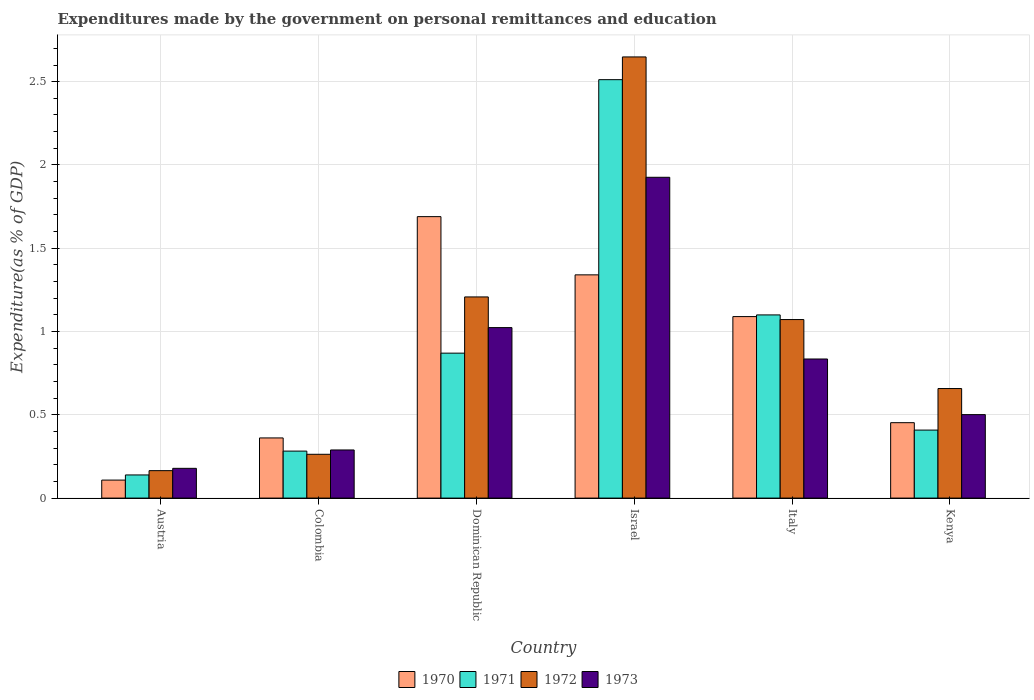How many bars are there on the 5th tick from the left?
Your response must be concise. 4. In how many cases, is the number of bars for a given country not equal to the number of legend labels?
Make the answer very short. 0. What is the expenditures made by the government on personal remittances and education in 1973 in Colombia?
Your answer should be compact. 0.29. Across all countries, what is the maximum expenditures made by the government on personal remittances and education in 1973?
Ensure brevity in your answer.  1.93. Across all countries, what is the minimum expenditures made by the government on personal remittances and education in 1972?
Provide a short and direct response. 0.16. In which country was the expenditures made by the government on personal remittances and education in 1972 maximum?
Give a very brief answer. Israel. What is the total expenditures made by the government on personal remittances and education in 1973 in the graph?
Provide a succinct answer. 4.75. What is the difference between the expenditures made by the government on personal remittances and education in 1972 in Colombia and that in Dominican Republic?
Offer a very short reply. -0.94. What is the difference between the expenditures made by the government on personal remittances and education in 1973 in Kenya and the expenditures made by the government on personal remittances and education in 1972 in Dominican Republic?
Make the answer very short. -0.71. What is the average expenditures made by the government on personal remittances and education in 1970 per country?
Offer a terse response. 0.84. What is the difference between the expenditures made by the government on personal remittances and education of/in 1972 and expenditures made by the government on personal remittances and education of/in 1970 in Italy?
Make the answer very short. -0.02. In how many countries, is the expenditures made by the government on personal remittances and education in 1971 greater than 0.4 %?
Offer a very short reply. 4. What is the ratio of the expenditures made by the government on personal remittances and education in 1972 in Austria to that in Dominican Republic?
Ensure brevity in your answer.  0.14. Is the expenditures made by the government on personal remittances and education in 1970 in Israel less than that in Kenya?
Your answer should be very brief. No. What is the difference between the highest and the second highest expenditures made by the government on personal remittances and education in 1971?
Make the answer very short. -0.23. What is the difference between the highest and the lowest expenditures made by the government on personal remittances and education in 1973?
Your answer should be compact. 1.75. In how many countries, is the expenditures made by the government on personal remittances and education in 1972 greater than the average expenditures made by the government on personal remittances and education in 1972 taken over all countries?
Keep it short and to the point. 3. Is it the case that in every country, the sum of the expenditures made by the government on personal remittances and education in 1970 and expenditures made by the government on personal remittances and education in 1972 is greater than the sum of expenditures made by the government on personal remittances and education in 1971 and expenditures made by the government on personal remittances and education in 1973?
Make the answer very short. No. What does the 3rd bar from the right in Israel represents?
Give a very brief answer. 1971. Is it the case that in every country, the sum of the expenditures made by the government on personal remittances and education in 1972 and expenditures made by the government on personal remittances and education in 1970 is greater than the expenditures made by the government on personal remittances and education in 1971?
Offer a terse response. Yes. Are all the bars in the graph horizontal?
Your answer should be very brief. No. How many countries are there in the graph?
Ensure brevity in your answer.  6. Does the graph contain any zero values?
Provide a succinct answer. No. Does the graph contain grids?
Give a very brief answer. Yes. Where does the legend appear in the graph?
Provide a short and direct response. Bottom center. How many legend labels are there?
Provide a succinct answer. 4. How are the legend labels stacked?
Your answer should be very brief. Horizontal. What is the title of the graph?
Your answer should be very brief. Expenditures made by the government on personal remittances and education. What is the label or title of the Y-axis?
Keep it short and to the point. Expenditure(as % of GDP). What is the Expenditure(as % of GDP) in 1970 in Austria?
Your response must be concise. 0.11. What is the Expenditure(as % of GDP) in 1971 in Austria?
Your response must be concise. 0.14. What is the Expenditure(as % of GDP) in 1972 in Austria?
Provide a short and direct response. 0.16. What is the Expenditure(as % of GDP) of 1973 in Austria?
Your answer should be very brief. 0.18. What is the Expenditure(as % of GDP) of 1970 in Colombia?
Keep it short and to the point. 0.36. What is the Expenditure(as % of GDP) of 1971 in Colombia?
Make the answer very short. 0.28. What is the Expenditure(as % of GDP) in 1972 in Colombia?
Provide a short and direct response. 0.26. What is the Expenditure(as % of GDP) in 1973 in Colombia?
Give a very brief answer. 0.29. What is the Expenditure(as % of GDP) of 1970 in Dominican Republic?
Your answer should be compact. 1.69. What is the Expenditure(as % of GDP) of 1971 in Dominican Republic?
Keep it short and to the point. 0.87. What is the Expenditure(as % of GDP) of 1972 in Dominican Republic?
Ensure brevity in your answer.  1.21. What is the Expenditure(as % of GDP) in 1973 in Dominican Republic?
Your response must be concise. 1.02. What is the Expenditure(as % of GDP) of 1970 in Israel?
Your answer should be compact. 1.34. What is the Expenditure(as % of GDP) in 1971 in Israel?
Your answer should be compact. 2.51. What is the Expenditure(as % of GDP) in 1972 in Israel?
Your response must be concise. 2.65. What is the Expenditure(as % of GDP) in 1973 in Israel?
Your response must be concise. 1.93. What is the Expenditure(as % of GDP) of 1970 in Italy?
Your answer should be very brief. 1.09. What is the Expenditure(as % of GDP) in 1971 in Italy?
Provide a short and direct response. 1.1. What is the Expenditure(as % of GDP) in 1972 in Italy?
Offer a very short reply. 1.07. What is the Expenditure(as % of GDP) of 1973 in Italy?
Ensure brevity in your answer.  0.84. What is the Expenditure(as % of GDP) in 1970 in Kenya?
Your response must be concise. 0.45. What is the Expenditure(as % of GDP) of 1971 in Kenya?
Offer a very short reply. 0.41. What is the Expenditure(as % of GDP) in 1972 in Kenya?
Provide a short and direct response. 0.66. What is the Expenditure(as % of GDP) of 1973 in Kenya?
Your response must be concise. 0.5. Across all countries, what is the maximum Expenditure(as % of GDP) of 1970?
Offer a terse response. 1.69. Across all countries, what is the maximum Expenditure(as % of GDP) of 1971?
Your response must be concise. 2.51. Across all countries, what is the maximum Expenditure(as % of GDP) in 1972?
Ensure brevity in your answer.  2.65. Across all countries, what is the maximum Expenditure(as % of GDP) in 1973?
Provide a succinct answer. 1.93. Across all countries, what is the minimum Expenditure(as % of GDP) in 1970?
Provide a succinct answer. 0.11. Across all countries, what is the minimum Expenditure(as % of GDP) of 1971?
Provide a short and direct response. 0.14. Across all countries, what is the minimum Expenditure(as % of GDP) in 1972?
Give a very brief answer. 0.16. Across all countries, what is the minimum Expenditure(as % of GDP) in 1973?
Your response must be concise. 0.18. What is the total Expenditure(as % of GDP) in 1970 in the graph?
Your answer should be very brief. 5.04. What is the total Expenditure(as % of GDP) of 1971 in the graph?
Your answer should be very brief. 5.31. What is the total Expenditure(as % of GDP) in 1972 in the graph?
Make the answer very short. 6.01. What is the total Expenditure(as % of GDP) of 1973 in the graph?
Give a very brief answer. 4.75. What is the difference between the Expenditure(as % of GDP) in 1970 in Austria and that in Colombia?
Give a very brief answer. -0.25. What is the difference between the Expenditure(as % of GDP) of 1971 in Austria and that in Colombia?
Make the answer very short. -0.14. What is the difference between the Expenditure(as % of GDP) of 1972 in Austria and that in Colombia?
Offer a terse response. -0.1. What is the difference between the Expenditure(as % of GDP) of 1973 in Austria and that in Colombia?
Make the answer very short. -0.11. What is the difference between the Expenditure(as % of GDP) of 1970 in Austria and that in Dominican Republic?
Your response must be concise. -1.58. What is the difference between the Expenditure(as % of GDP) in 1971 in Austria and that in Dominican Republic?
Your answer should be very brief. -0.73. What is the difference between the Expenditure(as % of GDP) in 1972 in Austria and that in Dominican Republic?
Give a very brief answer. -1.04. What is the difference between the Expenditure(as % of GDP) of 1973 in Austria and that in Dominican Republic?
Keep it short and to the point. -0.84. What is the difference between the Expenditure(as % of GDP) of 1970 in Austria and that in Israel?
Your answer should be very brief. -1.23. What is the difference between the Expenditure(as % of GDP) of 1971 in Austria and that in Israel?
Your answer should be compact. -2.37. What is the difference between the Expenditure(as % of GDP) in 1972 in Austria and that in Israel?
Ensure brevity in your answer.  -2.48. What is the difference between the Expenditure(as % of GDP) in 1973 in Austria and that in Israel?
Provide a succinct answer. -1.75. What is the difference between the Expenditure(as % of GDP) of 1970 in Austria and that in Italy?
Offer a terse response. -0.98. What is the difference between the Expenditure(as % of GDP) of 1971 in Austria and that in Italy?
Keep it short and to the point. -0.96. What is the difference between the Expenditure(as % of GDP) of 1972 in Austria and that in Italy?
Provide a short and direct response. -0.91. What is the difference between the Expenditure(as % of GDP) of 1973 in Austria and that in Italy?
Make the answer very short. -0.66. What is the difference between the Expenditure(as % of GDP) of 1970 in Austria and that in Kenya?
Provide a succinct answer. -0.34. What is the difference between the Expenditure(as % of GDP) of 1971 in Austria and that in Kenya?
Your answer should be compact. -0.27. What is the difference between the Expenditure(as % of GDP) of 1972 in Austria and that in Kenya?
Keep it short and to the point. -0.49. What is the difference between the Expenditure(as % of GDP) of 1973 in Austria and that in Kenya?
Provide a succinct answer. -0.32. What is the difference between the Expenditure(as % of GDP) in 1970 in Colombia and that in Dominican Republic?
Provide a short and direct response. -1.33. What is the difference between the Expenditure(as % of GDP) of 1971 in Colombia and that in Dominican Republic?
Provide a succinct answer. -0.59. What is the difference between the Expenditure(as % of GDP) in 1972 in Colombia and that in Dominican Republic?
Give a very brief answer. -0.94. What is the difference between the Expenditure(as % of GDP) of 1973 in Colombia and that in Dominican Republic?
Your response must be concise. -0.73. What is the difference between the Expenditure(as % of GDP) of 1970 in Colombia and that in Israel?
Offer a terse response. -0.98. What is the difference between the Expenditure(as % of GDP) in 1971 in Colombia and that in Israel?
Provide a short and direct response. -2.23. What is the difference between the Expenditure(as % of GDP) of 1972 in Colombia and that in Israel?
Your answer should be very brief. -2.39. What is the difference between the Expenditure(as % of GDP) in 1973 in Colombia and that in Israel?
Give a very brief answer. -1.64. What is the difference between the Expenditure(as % of GDP) of 1970 in Colombia and that in Italy?
Offer a very short reply. -0.73. What is the difference between the Expenditure(as % of GDP) of 1971 in Colombia and that in Italy?
Keep it short and to the point. -0.82. What is the difference between the Expenditure(as % of GDP) of 1972 in Colombia and that in Italy?
Ensure brevity in your answer.  -0.81. What is the difference between the Expenditure(as % of GDP) of 1973 in Colombia and that in Italy?
Your answer should be very brief. -0.55. What is the difference between the Expenditure(as % of GDP) of 1970 in Colombia and that in Kenya?
Ensure brevity in your answer.  -0.09. What is the difference between the Expenditure(as % of GDP) in 1971 in Colombia and that in Kenya?
Offer a terse response. -0.13. What is the difference between the Expenditure(as % of GDP) in 1972 in Colombia and that in Kenya?
Provide a short and direct response. -0.39. What is the difference between the Expenditure(as % of GDP) in 1973 in Colombia and that in Kenya?
Ensure brevity in your answer.  -0.21. What is the difference between the Expenditure(as % of GDP) in 1970 in Dominican Republic and that in Israel?
Give a very brief answer. 0.35. What is the difference between the Expenditure(as % of GDP) in 1971 in Dominican Republic and that in Israel?
Provide a succinct answer. -1.64. What is the difference between the Expenditure(as % of GDP) in 1972 in Dominican Republic and that in Israel?
Your response must be concise. -1.44. What is the difference between the Expenditure(as % of GDP) in 1973 in Dominican Republic and that in Israel?
Give a very brief answer. -0.9. What is the difference between the Expenditure(as % of GDP) of 1970 in Dominican Republic and that in Italy?
Ensure brevity in your answer.  0.6. What is the difference between the Expenditure(as % of GDP) in 1971 in Dominican Republic and that in Italy?
Your answer should be very brief. -0.23. What is the difference between the Expenditure(as % of GDP) of 1972 in Dominican Republic and that in Italy?
Make the answer very short. 0.14. What is the difference between the Expenditure(as % of GDP) in 1973 in Dominican Republic and that in Italy?
Offer a terse response. 0.19. What is the difference between the Expenditure(as % of GDP) in 1970 in Dominican Republic and that in Kenya?
Keep it short and to the point. 1.24. What is the difference between the Expenditure(as % of GDP) of 1971 in Dominican Republic and that in Kenya?
Offer a terse response. 0.46. What is the difference between the Expenditure(as % of GDP) of 1972 in Dominican Republic and that in Kenya?
Offer a terse response. 0.55. What is the difference between the Expenditure(as % of GDP) of 1973 in Dominican Republic and that in Kenya?
Your answer should be compact. 0.52. What is the difference between the Expenditure(as % of GDP) of 1970 in Israel and that in Italy?
Make the answer very short. 0.25. What is the difference between the Expenditure(as % of GDP) in 1971 in Israel and that in Italy?
Provide a succinct answer. 1.41. What is the difference between the Expenditure(as % of GDP) of 1972 in Israel and that in Italy?
Offer a very short reply. 1.58. What is the difference between the Expenditure(as % of GDP) in 1973 in Israel and that in Italy?
Your response must be concise. 1.09. What is the difference between the Expenditure(as % of GDP) of 1970 in Israel and that in Kenya?
Make the answer very short. 0.89. What is the difference between the Expenditure(as % of GDP) in 1971 in Israel and that in Kenya?
Make the answer very short. 2.1. What is the difference between the Expenditure(as % of GDP) in 1972 in Israel and that in Kenya?
Provide a short and direct response. 1.99. What is the difference between the Expenditure(as % of GDP) in 1973 in Israel and that in Kenya?
Make the answer very short. 1.42. What is the difference between the Expenditure(as % of GDP) in 1970 in Italy and that in Kenya?
Offer a very short reply. 0.64. What is the difference between the Expenditure(as % of GDP) in 1971 in Italy and that in Kenya?
Give a very brief answer. 0.69. What is the difference between the Expenditure(as % of GDP) of 1972 in Italy and that in Kenya?
Your answer should be very brief. 0.41. What is the difference between the Expenditure(as % of GDP) of 1973 in Italy and that in Kenya?
Provide a short and direct response. 0.33. What is the difference between the Expenditure(as % of GDP) of 1970 in Austria and the Expenditure(as % of GDP) of 1971 in Colombia?
Your answer should be very brief. -0.17. What is the difference between the Expenditure(as % of GDP) of 1970 in Austria and the Expenditure(as % of GDP) of 1972 in Colombia?
Provide a succinct answer. -0.15. What is the difference between the Expenditure(as % of GDP) of 1970 in Austria and the Expenditure(as % of GDP) of 1973 in Colombia?
Your answer should be very brief. -0.18. What is the difference between the Expenditure(as % of GDP) in 1971 in Austria and the Expenditure(as % of GDP) in 1972 in Colombia?
Your response must be concise. -0.12. What is the difference between the Expenditure(as % of GDP) of 1971 in Austria and the Expenditure(as % of GDP) of 1973 in Colombia?
Keep it short and to the point. -0.15. What is the difference between the Expenditure(as % of GDP) in 1972 in Austria and the Expenditure(as % of GDP) in 1973 in Colombia?
Provide a short and direct response. -0.12. What is the difference between the Expenditure(as % of GDP) of 1970 in Austria and the Expenditure(as % of GDP) of 1971 in Dominican Republic?
Keep it short and to the point. -0.76. What is the difference between the Expenditure(as % of GDP) of 1970 in Austria and the Expenditure(as % of GDP) of 1972 in Dominican Republic?
Give a very brief answer. -1.1. What is the difference between the Expenditure(as % of GDP) in 1970 in Austria and the Expenditure(as % of GDP) in 1973 in Dominican Republic?
Make the answer very short. -0.92. What is the difference between the Expenditure(as % of GDP) of 1971 in Austria and the Expenditure(as % of GDP) of 1972 in Dominican Republic?
Offer a terse response. -1.07. What is the difference between the Expenditure(as % of GDP) of 1971 in Austria and the Expenditure(as % of GDP) of 1973 in Dominican Republic?
Provide a short and direct response. -0.88. What is the difference between the Expenditure(as % of GDP) of 1972 in Austria and the Expenditure(as % of GDP) of 1973 in Dominican Republic?
Offer a terse response. -0.86. What is the difference between the Expenditure(as % of GDP) of 1970 in Austria and the Expenditure(as % of GDP) of 1971 in Israel?
Give a very brief answer. -2.4. What is the difference between the Expenditure(as % of GDP) in 1970 in Austria and the Expenditure(as % of GDP) in 1972 in Israel?
Provide a short and direct response. -2.54. What is the difference between the Expenditure(as % of GDP) of 1970 in Austria and the Expenditure(as % of GDP) of 1973 in Israel?
Offer a terse response. -1.82. What is the difference between the Expenditure(as % of GDP) of 1971 in Austria and the Expenditure(as % of GDP) of 1972 in Israel?
Ensure brevity in your answer.  -2.51. What is the difference between the Expenditure(as % of GDP) of 1971 in Austria and the Expenditure(as % of GDP) of 1973 in Israel?
Provide a succinct answer. -1.79. What is the difference between the Expenditure(as % of GDP) of 1972 in Austria and the Expenditure(as % of GDP) of 1973 in Israel?
Give a very brief answer. -1.76. What is the difference between the Expenditure(as % of GDP) of 1970 in Austria and the Expenditure(as % of GDP) of 1971 in Italy?
Offer a terse response. -0.99. What is the difference between the Expenditure(as % of GDP) in 1970 in Austria and the Expenditure(as % of GDP) in 1972 in Italy?
Make the answer very short. -0.96. What is the difference between the Expenditure(as % of GDP) in 1970 in Austria and the Expenditure(as % of GDP) in 1973 in Italy?
Give a very brief answer. -0.73. What is the difference between the Expenditure(as % of GDP) of 1971 in Austria and the Expenditure(as % of GDP) of 1972 in Italy?
Provide a short and direct response. -0.93. What is the difference between the Expenditure(as % of GDP) of 1971 in Austria and the Expenditure(as % of GDP) of 1973 in Italy?
Your answer should be compact. -0.7. What is the difference between the Expenditure(as % of GDP) in 1972 in Austria and the Expenditure(as % of GDP) in 1973 in Italy?
Provide a short and direct response. -0.67. What is the difference between the Expenditure(as % of GDP) in 1970 in Austria and the Expenditure(as % of GDP) in 1971 in Kenya?
Offer a very short reply. -0.3. What is the difference between the Expenditure(as % of GDP) of 1970 in Austria and the Expenditure(as % of GDP) of 1972 in Kenya?
Provide a short and direct response. -0.55. What is the difference between the Expenditure(as % of GDP) in 1970 in Austria and the Expenditure(as % of GDP) in 1973 in Kenya?
Provide a succinct answer. -0.39. What is the difference between the Expenditure(as % of GDP) in 1971 in Austria and the Expenditure(as % of GDP) in 1972 in Kenya?
Your response must be concise. -0.52. What is the difference between the Expenditure(as % of GDP) of 1971 in Austria and the Expenditure(as % of GDP) of 1973 in Kenya?
Provide a short and direct response. -0.36. What is the difference between the Expenditure(as % of GDP) in 1972 in Austria and the Expenditure(as % of GDP) in 1973 in Kenya?
Your answer should be very brief. -0.34. What is the difference between the Expenditure(as % of GDP) of 1970 in Colombia and the Expenditure(as % of GDP) of 1971 in Dominican Republic?
Your response must be concise. -0.51. What is the difference between the Expenditure(as % of GDP) of 1970 in Colombia and the Expenditure(as % of GDP) of 1972 in Dominican Republic?
Your answer should be very brief. -0.85. What is the difference between the Expenditure(as % of GDP) in 1970 in Colombia and the Expenditure(as % of GDP) in 1973 in Dominican Republic?
Offer a very short reply. -0.66. What is the difference between the Expenditure(as % of GDP) of 1971 in Colombia and the Expenditure(as % of GDP) of 1972 in Dominican Republic?
Ensure brevity in your answer.  -0.93. What is the difference between the Expenditure(as % of GDP) in 1971 in Colombia and the Expenditure(as % of GDP) in 1973 in Dominican Republic?
Provide a short and direct response. -0.74. What is the difference between the Expenditure(as % of GDP) in 1972 in Colombia and the Expenditure(as % of GDP) in 1973 in Dominican Republic?
Your answer should be compact. -0.76. What is the difference between the Expenditure(as % of GDP) of 1970 in Colombia and the Expenditure(as % of GDP) of 1971 in Israel?
Offer a terse response. -2.15. What is the difference between the Expenditure(as % of GDP) of 1970 in Colombia and the Expenditure(as % of GDP) of 1972 in Israel?
Your response must be concise. -2.29. What is the difference between the Expenditure(as % of GDP) of 1970 in Colombia and the Expenditure(as % of GDP) of 1973 in Israel?
Your answer should be compact. -1.56. What is the difference between the Expenditure(as % of GDP) of 1971 in Colombia and the Expenditure(as % of GDP) of 1972 in Israel?
Keep it short and to the point. -2.37. What is the difference between the Expenditure(as % of GDP) in 1971 in Colombia and the Expenditure(as % of GDP) in 1973 in Israel?
Keep it short and to the point. -1.64. What is the difference between the Expenditure(as % of GDP) of 1972 in Colombia and the Expenditure(as % of GDP) of 1973 in Israel?
Give a very brief answer. -1.66. What is the difference between the Expenditure(as % of GDP) of 1970 in Colombia and the Expenditure(as % of GDP) of 1971 in Italy?
Offer a terse response. -0.74. What is the difference between the Expenditure(as % of GDP) in 1970 in Colombia and the Expenditure(as % of GDP) in 1972 in Italy?
Offer a very short reply. -0.71. What is the difference between the Expenditure(as % of GDP) of 1970 in Colombia and the Expenditure(as % of GDP) of 1973 in Italy?
Your response must be concise. -0.47. What is the difference between the Expenditure(as % of GDP) in 1971 in Colombia and the Expenditure(as % of GDP) in 1972 in Italy?
Keep it short and to the point. -0.79. What is the difference between the Expenditure(as % of GDP) in 1971 in Colombia and the Expenditure(as % of GDP) in 1973 in Italy?
Keep it short and to the point. -0.55. What is the difference between the Expenditure(as % of GDP) of 1972 in Colombia and the Expenditure(as % of GDP) of 1973 in Italy?
Give a very brief answer. -0.57. What is the difference between the Expenditure(as % of GDP) in 1970 in Colombia and the Expenditure(as % of GDP) in 1971 in Kenya?
Offer a terse response. -0.05. What is the difference between the Expenditure(as % of GDP) in 1970 in Colombia and the Expenditure(as % of GDP) in 1972 in Kenya?
Ensure brevity in your answer.  -0.3. What is the difference between the Expenditure(as % of GDP) in 1970 in Colombia and the Expenditure(as % of GDP) in 1973 in Kenya?
Offer a very short reply. -0.14. What is the difference between the Expenditure(as % of GDP) in 1971 in Colombia and the Expenditure(as % of GDP) in 1972 in Kenya?
Offer a very short reply. -0.38. What is the difference between the Expenditure(as % of GDP) of 1971 in Colombia and the Expenditure(as % of GDP) of 1973 in Kenya?
Provide a succinct answer. -0.22. What is the difference between the Expenditure(as % of GDP) of 1972 in Colombia and the Expenditure(as % of GDP) of 1973 in Kenya?
Provide a short and direct response. -0.24. What is the difference between the Expenditure(as % of GDP) of 1970 in Dominican Republic and the Expenditure(as % of GDP) of 1971 in Israel?
Make the answer very short. -0.82. What is the difference between the Expenditure(as % of GDP) in 1970 in Dominican Republic and the Expenditure(as % of GDP) in 1972 in Israel?
Keep it short and to the point. -0.96. What is the difference between the Expenditure(as % of GDP) in 1970 in Dominican Republic and the Expenditure(as % of GDP) in 1973 in Israel?
Keep it short and to the point. -0.24. What is the difference between the Expenditure(as % of GDP) of 1971 in Dominican Republic and the Expenditure(as % of GDP) of 1972 in Israel?
Provide a succinct answer. -1.78. What is the difference between the Expenditure(as % of GDP) in 1971 in Dominican Republic and the Expenditure(as % of GDP) in 1973 in Israel?
Your answer should be very brief. -1.06. What is the difference between the Expenditure(as % of GDP) of 1972 in Dominican Republic and the Expenditure(as % of GDP) of 1973 in Israel?
Your response must be concise. -0.72. What is the difference between the Expenditure(as % of GDP) in 1970 in Dominican Republic and the Expenditure(as % of GDP) in 1971 in Italy?
Your answer should be very brief. 0.59. What is the difference between the Expenditure(as % of GDP) of 1970 in Dominican Republic and the Expenditure(as % of GDP) of 1972 in Italy?
Your response must be concise. 0.62. What is the difference between the Expenditure(as % of GDP) in 1970 in Dominican Republic and the Expenditure(as % of GDP) in 1973 in Italy?
Provide a short and direct response. 0.85. What is the difference between the Expenditure(as % of GDP) in 1971 in Dominican Republic and the Expenditure(as % of GDP) in 1972 in Italy?
Provide a short and direct response. -0.2. What is the difference between the Expenditure(as % of GDP) in 1971 in Dominican Republic and the Expenditure(as % of GDP) in 1973 in Italy?
Your answer should be very brief. 0.04. What is the difference between the Expenditure(as % of GDP) in 1972 in Dominican Republic and the Expenditure(as % of GDP) in 1973 in Italy?
Ensure brevity in your answer.  0.37. What is the difference between the Expenditure(as % of GDP) of 1970 in Dominican Republic and the Expenditure(as % of GDP) of 1971 in Kenya?
Keep it short and to the point. 1.28. What is the difference between the Expenditure(as % of GDP) of 1970 in Dominican Republic and the Expenditure(as % of GDP) of 1972 in Kenya?
Ensure brevity in your answer.  1.03. What is the difference between the Expenditure(as % of GDP) of 1970 in Dominican Republic and the Expenditure(as % of GDP) of 1973 in Kenya?
Provide a succinct answer. 1.19. What is the difference between the Expenditure(as % of GDP) in 1971 in Dominican Republic and the Expenditure(as % of GDP) in 1972 in Kenya?
Your answer should be very brief. 0.21. What is the difference between the Expenditure(as % of GDP) in 1971 in Dominican Republic and the Expenditure(as % of GDP) in 1973 in Kenya?
Ensure brevity in your answer.  0.37. What is the difference between the Expenditure(as % of GDP) of 1972 in Dominican Republic and the Expenditure(as % of GDP) of 1973 in Kenya?
Offer a very short reply. 0.71. What is the difference between the Expenditure(as % of GDP) of 1970 in Israel and the Expenditure(as % of GDP) of 1971 in Italy?
Make the answer very short. 0.24. What is the difference between the Expenditure(as % of GDP) in 1970 in Israel and the Expenditure(as % of GDP) in 1972 in Italy?
Offer a very short reply. 0.27. What is the difference between the Expenditure(as % of GDP) in 1970 in Israel and the Expenditure(as % of GDP) in 1973 in Italy?
Your answer should be very brief. 0.51. What is the difference between the Expenditure(as % of GDP) of 1971 in Israel and the Expenditure(as % of GDP) of 1972 in Italy?
Give a very brief answer. 1.44. What is the difference between the Expenditure(as % of GDP) in 1971 in Israel and the Expenditure(as % of GDP) in 1973 in Italy?
Give a very brief answer. 1.68. What is the difference between the Expenditure(as % of GDP) in 1972 in Israel and the Expenditure(as % of GDP) in 1973 in Italy?
Give a very brief answer. 1.81. What is the difference between the Expenditure(as % of GDP) in 1970 in Israel and the Expenditure(as % of GDP) in 1971 in Kenya?
Make the answer very short. 0.93. What is the difference between the Expenditure(as % of GDP) of 1970 in Israel and the Expenditure(as % of GDP) of 1972 in Kenya?
Ensure brevity in your answer.  0.68. What is the difference between the Expenditure(as % of GDP) in 1970 in Israel and the Expenditure(as % of GDP) in 1973 in Kenya?
Your answer should be very brief. 0.84. What is the difference between the Expenditure(as % of GDP) in 1971 in Israel and the Expenditure(as % of GDP) in 1972 in Kenya?
Provide a succinct answer. 1.85. What is the difference between the Expenditure(as % of GDP) in 1971 in Israel and the Expenditure(as % of GDP) in 1973 in Kenya?
Provide a short and direct response. 2.01. What is the difference between the Expenditure(as % of GDP) in 1972 in Israel and the Expenditure(as % of GDP) in 1973 in Kenya?
Offer a terse response. 2.15. What is the difference between the Expenditure(as % of GDP) of 1970 in Italy and the Expenditure(as % of GDP) of 1971 in Kenya?
Ensure brevity in your answer.  0.68. What is the difference between the Expenditure(as % of GDP) in 1970 in Italy and the Expenditure(as % of GDP) in 1972 in Kenya?
Provide a succinct answer. 0.43. What is the difference between the Expenditure(as % of GDP) of 1970 in Italy and the Expenditure(as % of GDP) of 1973 in Kenya?
Your answer should be very brief. 0.59. What is the difference between the Expenditure(as % of GDP) in 1971 in Italy and the Expenditure(as % of GDP) in 1972 in Kenya?
Ensure brevity in your answer.  0.44. What is the difference between the Expenditure(as % of GDP) of 1971 in Italy and the Expenditure(as % of GDP) of 1973 in Kenya?
Your answer should be very brief. 0.6. What is the difference between the Expenditure(as % of GDP) of 1972 in Italy and the Expenditure(as % of GDP) of 1973 in Kenya?
Your answer should be compact. 0.57. What is the average Expenditure(as % of GDP) in 1970 per country?
Your response must be concise. 0.84. What is the average Expenditure(as % of GDP) of 1971 per country?
Your answer should be compact. 0.89. What is the average Expenditure(as % of GDP) in 1972 per country?
Offer a terse response. 1. What is the average Expenditure(as % of GDP) in 1973 per country?
Provide a succinct answer. 0.79. What is the difference between the Expenditure(as % of GDP) in 1970 and Expenditure(as % of GDP) in 1971 in Austria?
Provide a succinct answer. -0.03. What is the difference between the Expenditure(as % of GDP) of 1970 and Expenditure(as % of GDP) of 1972 in Austria?
Give a very brief answer. -0.06. What is the difference between the Expenditure(as % of GDP) of 1970 and Expenditure(as % of GDP) of 1973 in Austria?
Give a very brief answer. -0.07. What is the difference between the Expenditure(as % of GDP) in 1971 and Expenditure(as % of GDP) in 1972 in Austria?
Your answer should be compact. -0.03. What is the difference between the Expenditure(as % of GDP) in 1971 and Expenditure(as % of GDP) in 1973 in Austria?
Provide a succinct answer. -0.04. What is the difference between the Expenditure(as % of GDP) in 1972 and Expenditure(as % of GDP) in 1973 in Austria?
Your response must be concise. -0.01. What is the difference between the Expenditure(as % of GDP) in 1970 and Expenditure(as % of GDP) in 1971 in Colombia?
Offer a very short reply. 0.08. What is the difference between the Expenditure(as % of GDP) in 1970 and Expenditure(as % of GDP) in 1972 in Colombia?
Offer a terse response. 0.1. What is the difference between the Expenditure(as % of GDP) in 1970 and Expenditure(as % of GDP) in 1973 in Colombia?
Give a very brief answer. 0.07. What is the difference between the Expenditure(as % of GDP) in 1971 and Expenditure(as % of GDP) in 1972 in Colombia?
Provide a succinct answer. 0.02. What is the difference between the Expenditure(as % of GDP) in 1971 and Expenditure(as % of GDP) in 1973 in Colombia?
Your answer should be very brief. -0.01. What is the difference between the Expenditure(as % of GDP) in 1972 and Expenditure(as % of GDP) in 1973 in Colombia?
Provide a short and direct response. -0.03. What is the difference between the Expenditure(as % of GDP) of 1970 and Expenditure(as % of GDP) of 1971 in Dominican Republic?
Your response must be concise. 0.82. What is the difference between the Expenditure(as % of GDP) in 1970 and Expenditure(as % of GDP) in 1972 in Dominican Republic?
Give a very brief answer. 0.48. What is the difference between the Expenditure(as % of GDP) of 1970 and Expenditure(as % of GDP) of 1973 in Dominican Republic?
Your response must be concise. 0.67. What is the difference between the Expenditure(as % of GDP) in 1971 and Expenditure(as % of GDP) in 1972 in Dominican Republic?
Your answer should be very brief. -0.34. What is the difference between the Expenditure(as % of GDP) of 1971 and Expenditure(as % of GDP) of 1973 in Dominican Republic?
Offer a very short reply. -0.15. What is the difference between the Expenditure(as % of GDP) of 1972 and Expenditure(as % of GDP) of 1973 in Dominican Republic?
Give a very brief answer. 0.18. What is the difference between the Expenditure(as % of GDP) in 1970 and Expenditure(as % of GDP) in 1971 in Israel?
Make the answer very short. -1.17. What is the difference between the Expenditure(as % of GDP) of 1970 and Expenditure(as % of GDP) of 1972 in Israel?
Your answer should be very brief. -1.31. What is the difference between the Expenditure(as % of GDP) in 1970 and Expenditure(as % of GDP) in 1973 in Israel?
Provide a short and direct response. -0.59. What is the difference between the Expenditure(as % of GDP) in 1971 and Expenditure(as % of GDP) in 1972 in Israel?
Your response must be concise. -0.14. What is the difference between the Expenditure(as % of GDP) of 1971 and Expenditure(as % of GDP) of 1973 in Israel?
Offer a terse response. 0.59. What is the difference between the Expenditure(as % of GDP) in 1972 and Expenditure(as % of GDP) in 1973 in Israel?
Your answer should be very brief. 0.72. What is the difference between the Expenditure(as % of GDP) in 1970 and Expenditure(as % of GDP) in 1971 in Italy?
Offer a very short reply. -0.01. What is the difference between the Expenditure(as % of GDP) of 1970 and Expenditure(as % of GDP) of 1972 in Italy?
Ensure brevity in your answer.  0.02. What is the difference between the Expenditure(as % of GDP) of 1970 and Expenditure(as % of GDP) of 1973 in Italy?
Ensure brevity in your answer.  0.25. What is the difference between the Expenditure(as % of GDP) in 1971 and Expenditure(as % of GDP) in 1972 in Italy?
Make the answer very short. 0.03. What is the difference between the Expenditure(as % of GDP) of 1971 and Expenditure(as % of GDP) of 1973 in Italy?
Ensure brevity in your answer.  0.26. What is the difference between the Expenditure(as % of GDP) of 1972 and Expenditure(as % of GDP) of 1973 in Italy?
Give a very brief answer. 0.24. What is the difference between the Expenditure(as % of GDP) of 1970 and Expenditure(as % of GDP) of 1971 in Kenya?
Provide a succinct answer. 0.04. What is the difference between the Expenditure(as % of GDP) in 1970 and Expenditure(as % of GDP) in 1972 in Kenya?
Your response must be concise. -0.2. What is the difference between the Expenditure(as % of GDP) in 1970 and Expenditure(as % of GDP) in 1973 in Kenya?
Provide a succinct answer. -0.05. What is the difference between the Expenditure(as % of GDP) in 1971 and Expenditure(as % of GDP) in 1972 in Kenya?
Your response must be concise. -0.25. What is the difference between the Expenditure(as % of GDP) in 1971 and Expenditure(as % of GDP) in 1973 in Kenya?
Offer a very short reply. -0.09. What is the difference between the Expenditure(as % of GDP) of 1972 and Expenditure(as % of GDP) of 1973 in Kenya?
Keep it short and to the point. 0.16. What is the ratio of the Expenditure(as % of GDP) in 1970 in Austria to that in Colombia?
Your answer should be very brief. 0.3. What is the ratio of the Expenditure(as % of GDP) in 1971 in Austria to that in Colombia?
Give a very brief answer. 0.49. What is the ratio of the Expenditure(as % of GDP) in 1972 in Austria to that in Colombia?
Make the answer very short. 0.63. What is the ratio of the Expenditure(as % of GDP) in 1973 in Austria to that in Colombia?
Make the answer very short. 0.62. What is the ratio of the Expenditure(as % of GDP) in 1970 in Austria to that in Dominican Republic?
Give a very brief answer. 0.06. What is the ratio of the Expenditure(as % of GDP) in 1971 in Austria to that in Dominican Republic?
Your response must be concise. 0.16. What is the ratio of the Expenditure(as % of GDP) of 1972 in Austria to that in Dominican Republic?
Your response must be concise. 0.14. What is the ratio of the Expenditure(as % of GDP) of 1973 in Austria to that in Dominican Republic?
Keep it short and to the point. 0.17. What is the ratio of the Expenditure(as % of GDP) in 1970 in Austria to that in Israel?
Provide a succinct answer. 0.08. What is the ratio of the Expenditure(as % of GDP) in 1971 in Austria to that in Israel?
Your answer should be compact. 0.06. What is the ratio of the Expenditure(as % of GDP) in 1972 in Austria to that in Israel?
Ensure brevity in your answer.  0.06. What is the ratio of the Expenditure(as % of GDP) in 1973 in Austria to that in Israel?
Make the answer very short. 0.09. What is the ratio of the Expenditure(as % of GDP) of 1970 in Austria to that in Italy?
Your response must be concise. 0.1. What is the ratio of the Expenditure(as % of GDP) in 1971 in Austria to that in Italy?
Provide a succinct answer. 0.13. What is the ratio of the Expenditure(as % of GDP) of 1972 in Austria to that in Italy?
Ensure brevity in your answer.  0.15. What is the ratio of the Expenditure(as % of GDP) of 1973 in Austria to that in Italy?
Give a very brief answer. 0.21. What is the ratio of the Expenditure(as % of GDP) of 1970 in Austria to that in Kenya?
Provide a short and direct response. 0.24. What is the ratio of the Expenditure(as % of GDP) in 1971 in Austria to that in Kenya?
Provide a short and direct response. 0.34. What is the ratio of the Expenditure(as % of GDP) in 1972 in Austria to that in Kenya?
Keep it short and to the point. 0.25. What is the ratio of the Expenditure(as % of GDP) in 1973 in Austria to that in Kenya?
Your answer should be very brief. 0.36. What is the ratio of the Expenditure(as % of GDP) of 1970 in Colombia to that in Dominican Republic?
Your answer should be compact. 0.21. What is the ratio of the Expenditure(as % of GDP) of 1971 in Colombia to that in Dominican Republic?
Your answer should be compact. 0.32. What is the ratio of the Expenditure(as % of GDP) of 1972 in Colombia to that in Dominican Republic?
Offer a very short reply. 0.22. What is the ratio of the Expenditure(as % of GDP) of 1973 in Colombia to that in Dominican Republic?
Offer a terse response. 0.28. What is the ratio of the Expenditure(as % of GDP) of 1970 in Colombia to that in Israel?
Provide a succinct answer. 0.27. What is the ratio of the Expenditure(as % of GDP) of 1971 in Colombia to that in Israel?
Your answer should be very brief. 0.11. What is the ratio of the Expenditure(as % of GDP) in 1972 in Colombia to that in Israel?
Offer a very short reply. 0.1. What is the ratio of the Expenditure(as % of GDP) in 1973 in Colombia to that in Israel?
Your answer should be very brief. 0.15. What is the ratio of the Expenditure(as % of GDP) of 1970 in Colombia to that in Italy?
Your answer should be compact. 0.33. What is the ratio of the Expenditure(as % of GDP) in 1971 in Colombia to that in Italy?
Offer a terse response. 0.26. What is the ratio of the Expenditure(as % of GDP) in 1972 in Colombia to that in Italy?
Your answer should be compact. 0.25. What is the ratio of the Expenditure(as % of GDP) of 1973 in Colombia to that in Italy?
Provide a short and direct response. 0.35. What is the ratio of the Expenditure(as % of GDP) of 1970 in Colombia to that in Kenya?
Your answer should be very brief. 0.8. What is the ratio of the Expenditure(as % of GDP) of 1971 in Colombia to that in Kenya?
Provide a short and direct response. 0.69. What is the ratio of the Expenditure(as % of GDP) in 1972 in Colombia to that in Kenya?
Give a very brief answer. 0.4. What is the ratio of the Expenditure(as % of GDP) in 1973 in Colombia to that in Kenya?
Offer a terse response. 0.58. What is the ratio of the Expenditure(as % of GDP) in 1970 in Dominican Republic to that in Israel?
Offer a terse response. 1.26. What is the ratio of the Expenditure(as % of GDP) of 1971 in Dominican Republic to that in Israel?
Provide a succinct answer. 0.35. What is the ratio of the Expenditure(as % of GDP) of 1972 in Dominican Republic to that in Israel?
Your answer should be compact. 0.46. What is the ratio of the Expenditure(as % of GDP) in 1973 in Dominican Republic to that in Israel?
Your answer should be very brief. 0.53. What is the ratio of the Expenditure(as % of GDP) of 1970 in Dominican Republic to that in Italy?
Offer a very short reply. 1.55. What is the ratio of the Expenditure(as % of GDP) in 1971 in Dominican Republic to that in Italy?
Provide a short and direct response. 0.79. What is the ratio of the Expenditure(as % of GDP) of 1972 in Dominican Republic to that in Italy?
Provide a short and direct response. 1.13. What is the ratio of the Expenditure(as % of GDP) in 1973 in Dominican Republic to that in Italy?
Provide a short and direct response. 1.23. What is the ratio of the Expenditure(as % of GDP) of 1970 in Dominican Republic to that in Kenya?
Your answer should be compact. 3.73. What is the ratio of the Expenditure(as % of GDP) of 1971 in Dominican Republic to that in Kenya?
Offer a very short reply. 2.13. What is the ratio of the Expenditure(as % of GDP) of 1972 in Dominican Republic to that in Kenya?
Keep it short and to the point. 1.84. What is the ratio of the Expenditure(as % of GDP) of 1973 in Dominican Republic to that in Kenya?
Your answer should be very brief. 2.04. What is the ratio of the Expenditure(as % of GDP) of 1970 in Israel to that in Italy?
Your answer should be very brief. 1.23. What is the ratio of the Expenditure(as % of GDP) of 1971 in Israel to that in Italy?
Your response must be concise. 2.28. What is the ratio of the Expenditure(as % of GDP) of 1972 in Israel to that in Italy?
Make the answer very short. 2.47. What is the ratio of the Expenditure(as % of GDP) of 1973 in Israel to that in Italy?
Make the answer very short. 2.31. What is the ratio of the Expenditure(as % of GDP) of 1970 in Israel to that in Kenya?
Make the answer very short. 2.96. What is the ratio of the Expenditure(as % of GDP) in 1971 in Israel to that in Kenya?
Keep it short and to the point. 6.15. What is the ratio of the Expenditure(as % of GDP) in 1972 in Israel to that in Kenya?
Your answer should be compact. 4.03. What is the ratio of the Expenditure(as % of GDP) in 1973 in Israel to that in Kenya?
Ensure brevity in your answer.  3.84. What is the ratio of the Expenditure(as % of GDP) of 1970 in Italy to that in Kenya?
Your answer should be compact. 2.41. What is the ratio of the Expenditure(as % of GDP) in 1971 in Italy to that in Kenya?
Offer a very short reply. 2.69. What is the ratio of the Expenditure(as % of GDP) of 1972 in Italy to that in Kenya?
Ensure brevity in your answer.  1.63. What is the ratio of the Expenditure(as % of GDP) in 1973 in Italy to that in Kenya?
Give a very brief answer. 1.67. What is the difference between the highest and the second highest Expenditure(as % of GDP) of 1970?
Ensure brevity in your answer.  0.35. What is the difference between the highest and the second highest Expenditure(as % of GDP) in 1971?
Offer a very short reply. 1.41. What is the difference between the highest and the second highest Expenditure(as % of GDP) of 1972?
Ensure brevity in your answer.  1.44. What is the difference between the highest and the second highest Expenditure(as % of GDP) in 1973?
Your answer should be very brief. 0.9. What is the difference between the highest and the lowest Expenditure(as % of GDP) of 1970?
Make the answer very short. 1.58. What is the difference between the highest and the lowest Expenditure(as % of GDP) of 1971?
Provide a short and direct response. 2.37. What is the difference between the highest and the lowest Expenditure(as % of GDP) of 1972?
Offer a very short reply. 2.48. What is the difference between the highest and the lowest Expenditure(as % of GDP) in 1973?
Offer a very short reply. 1.75. 